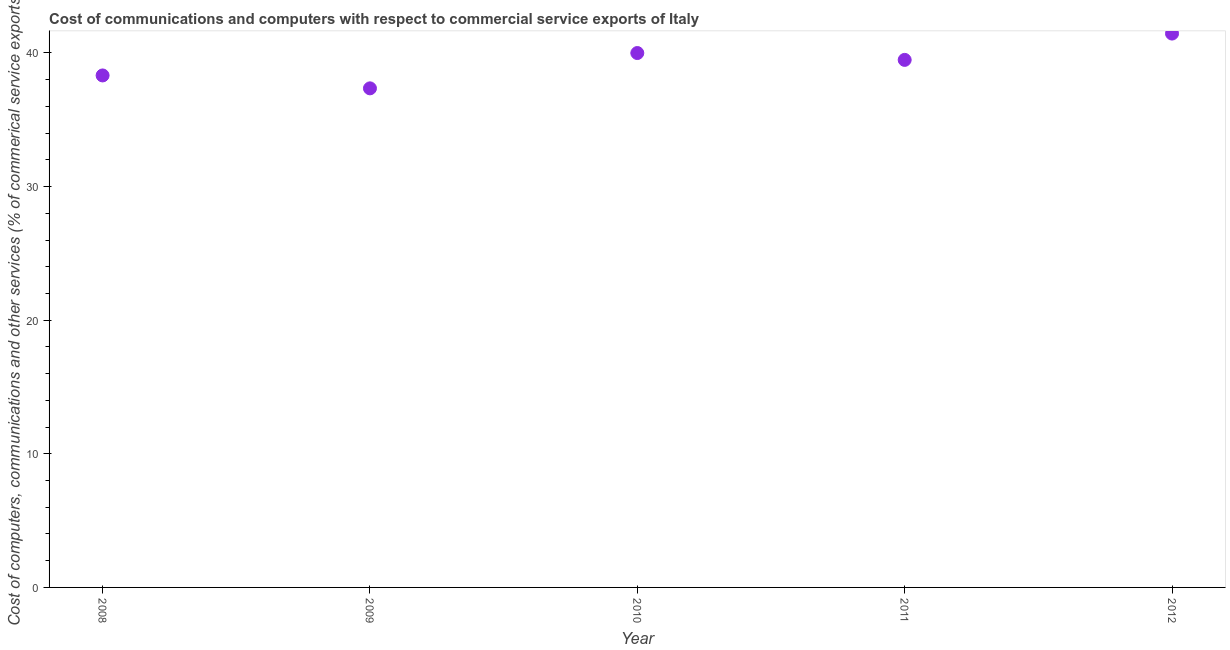What is the cost of communications in 2011?
Your answer should be compact. 39.48. Across all years, what is the maximum cost of communications?
Keep it short and to the point. 41.45. Across all years, what is the minimum  computer and other services?
Offer a very short reply. 37.35. What is the sum of the  computer and other services?
Make the answer very short. 196.6. What is the difference between the  computer and other services in 2008 and 2009?
Make the answer very short. 0.97. What is the average  computer and other services per year?
Provide a short and direct response. 39.32. What is the median cost of communications?
Keep it short and to the point. 39.48. Do a majority of the years between 2011 and 2010 (inclusive) have cost of communications greater than 2 %?
Provide a succinct answer. No. What is the ratio of the  computer and other services in 2009 to that in 2012?
Make the answer very short. 0.9. Is the difference between the  computer and other services in 2011 and 2012 greater than the difference between any two years?
Your response must be concise. No. What is the difference between the highest and the second highest  computer and other services?
Your answer should be very brief. 1.46. What is the difference between the highest and the lowest  computer and other services?
Your response must be concise. 4.1. How many dotlines are there?
Keep it short and to the point. 1. What is the difference between two consecutive major ticks on the Y-axis?
Provide a short and direct response. 10. What is the title of the graph?
Your response must be concise. Cost of communications and computers with respect to commercial service exports of Italy. What is the label or title of the Y-axis?
Give a very brief answer. Cost of computers, communications and other services (% of commerical service exports). What is the Cost of computers, communications and other services (% of commerical service exports) in 2008?
Make the answer very short. 38.32. What is the Cost of computers, communications and other services (% of commerical service exports) in 2009?
Offer a very short reply. 37.35. What is the Cost of computers, communications and other services (% of commerical service exports) in 2010?
Give a very brief answer. 40. What is the Cost of computers, communications and other services (% of commerical service exports) in 2011?
Offer a very short reply. 39.48. What is the Cost of computers, communications and other services (% of commerical service exports) in 2012?
Your response must be concise. 41.45. What is the difference between the Cost of computers, communications and other services (% of commerical service exports) in 2008 and 2009?
Offer a very short reply. 0.97. What is the difference between the Cost of computers, communications and other services (% of commerical service exports) in 2008 and 2010?
Your response must be concise. -1.68. What is the difference between the Cost of computers, communications and other services (% of commerical service exports) in 2008 and 2011?
Offer a very short reply. -1.16. What is the difference between the Cost of computers, communications and other services (% of commerical service exports) in 2008 and 2012?
Offer a very short reply. -3.13. What is the difference between the Cost of computers, communications and other services (% of commerical service exports) in 2009 and 2010?
Your answer should be very brief. -2.64. What is the difference between the Cost of computers, communications and other services (% of commerical service exports) in 2009 and 2011?
Your answer should be compact. -2.13. What is the difference between the Cost of computers, communications and other services (% of commerical service exports) in 2009 and 2012?
Your answer should be very brief. -4.1. What is the difference between the Cost of computers, communications and other services (% of commerical service exports) in 2010 and 2011?
Your response must be concise. 0.51. What is the difference between the Cost of computers, communications and other services (% of commerical service exports) in 2010 and 2012?
Provide a succinct answer. -1.46. What is the difference between the Cost of computers, communications and other services (% of commerical service exports) in 2011 and 2012?
Your response must be concise. -1.97. What is the ratio of the Cost of computers, communications and other services (% of commerical service exports) in 2008 to that in 2010?
Provide a succinct answer. 0.96. What is the ratio of the Cost of computers, communications and other services (% of commerical service exports) in 2008 to that in 2012?
Ensure brevity in your answer.  0.92. What is the ratio of the Cost of computers, communications and other services (% of commerical service exports) in 2009 to that in 2010?
Keep it short and to the point. 0.93. What is the ratio of the Cost of computers, communications and other services (% of commerical service exports) in 2009 to that in 2011?
Provide a short and direct response. 0.95. What is the ratio of the Cost of computers, communications and other services (% of commerical service exports) in 2009 to that in 2012?
Provide a succinct answer. 0.9. What is the ratio of the Cost of computers, communications and other services (% of commerical service exports) in 2010 to that in 2011?
Ensure brevity in your answer.  1.01. What is the ratio of the Cost of computers, communications and other services (% of commerical service exports) in 2010 to that in 2012?
Ensure brevity in your answer.  0.96. What is the ratio of the Cost of computers, communications and other services (% of commerical service exports) in 2011 to that in 2012?
Your answer should be compact. 0.95. 